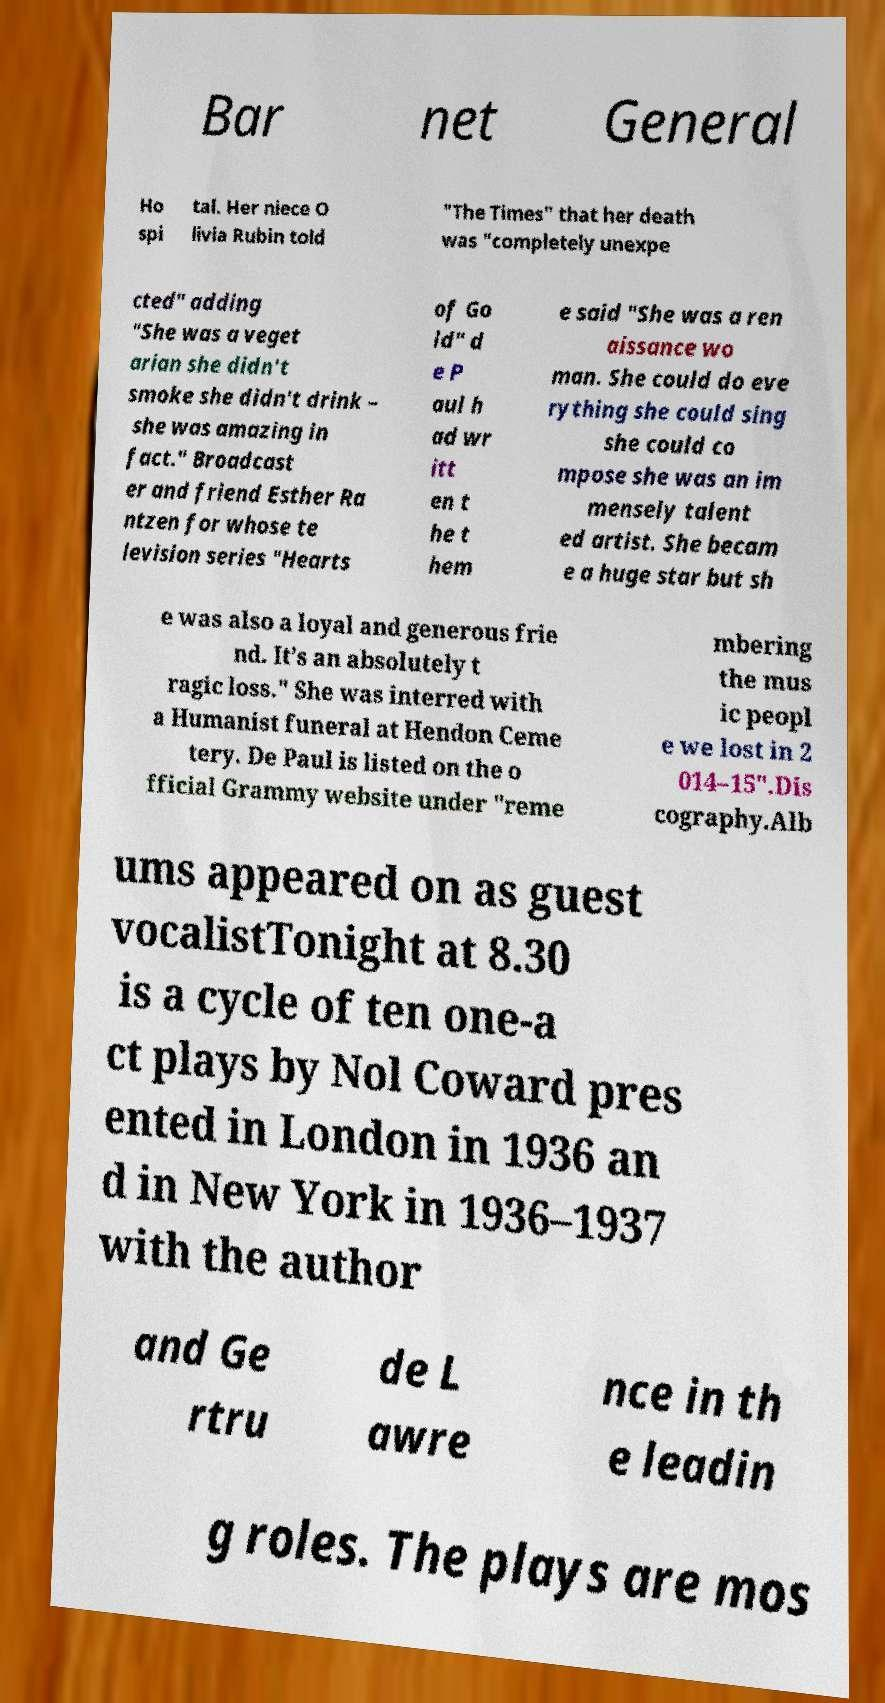Could you assist in decoding the text presented in this image and type it out clearly? Bar net General Ho spi tal. Her niece O livia Rubin told "The Times" that her death was "completely unexpe cted" adding "She was a veget arian she didn't smoke she didn't drink – she was amazing in fact." Broadcast er and friend Esther Ra ntzen for whose te levision series "Hearts of Go ld" d e P aul h ad wr itt en t he t hem e said "She was a ren aissance wo man. She could do eve rything she could sing she could co mpose she was an im mensely talent ed artist. She becam e a huge star but sh e was also a loyal and generous frie nd. It’s an absolutely t ragic loss." She was interred with a Humanist funeral at Hendon Ceme tery. De Paul is listed on the o fficial Grammy website under "reme mbering the mus ic peopl e we lost in 2 014–15".Dis cography.Alb ums appeared on as guest vocalistTonight at 8.30 is a cycle of ten one-a ct plays by Nol Coward pres ented in London in 1936 an d in New York in 1936–1937 with the author and Ge rtru de L awre nce in th e leadin g roles. The plays are mos 